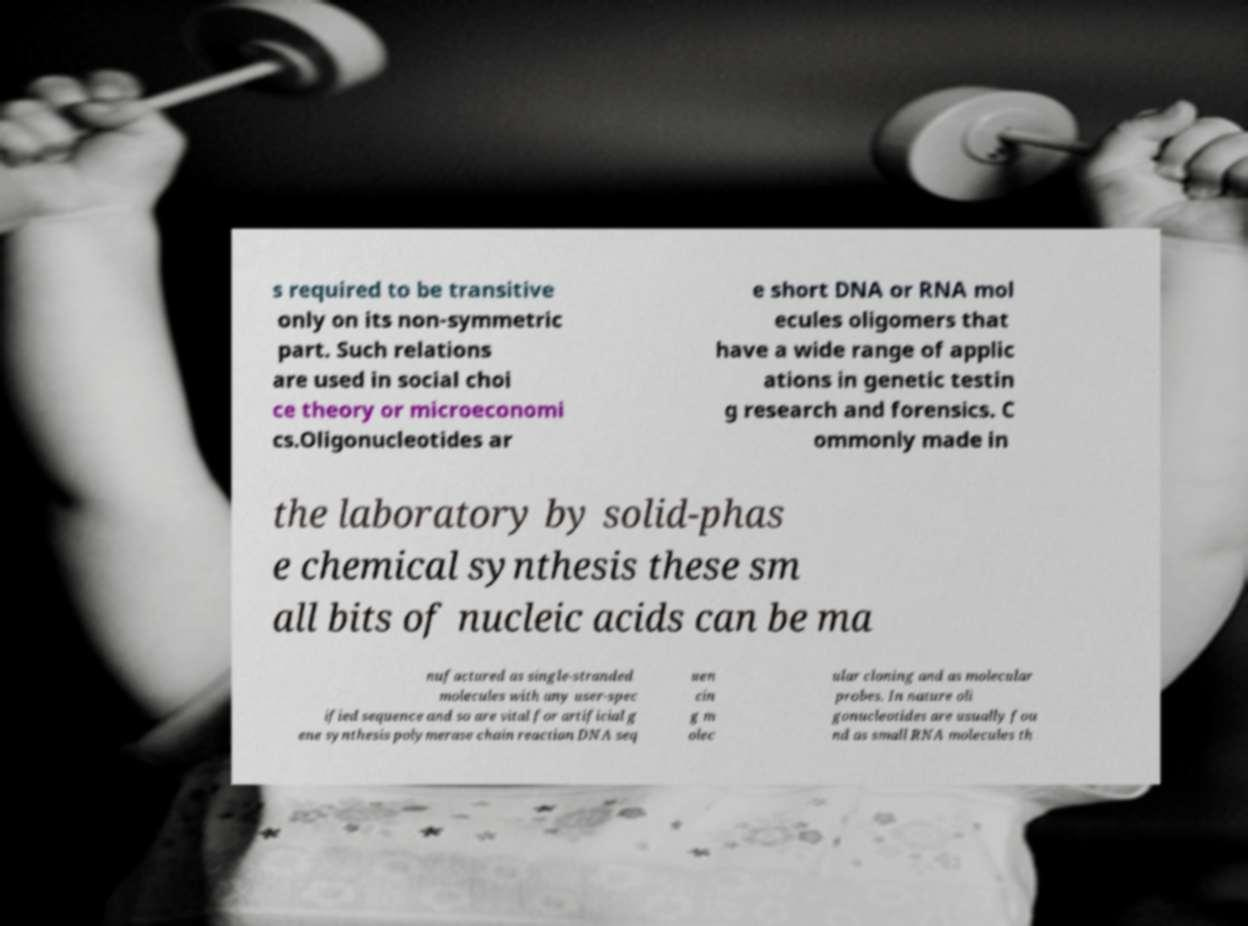Could you assist in decoding the text presented in this image and type it out clearly? s required to be transitive only on its non-symmetric part. Such relations are used in social choi ce theory or microeconomi cs.Oligonucleotides ar e short DNA or RNA mol ecules oligomers that have a wide range of applic ations in genetic testin g research and forensics. C ommonly made in the laboratory by solid-phas e chemical synthesis these sm all bits of nucleic acids can be ma nufactured as single-stranded molecules with any user-spec ified sequence and so are vital for artificial g ene synthesis polymerase chain reaction DNA seq uen cin g m olec ular cloning and as molecular probes. In nature oli gonucleotides are usually fou nd as small RNA molecules th 